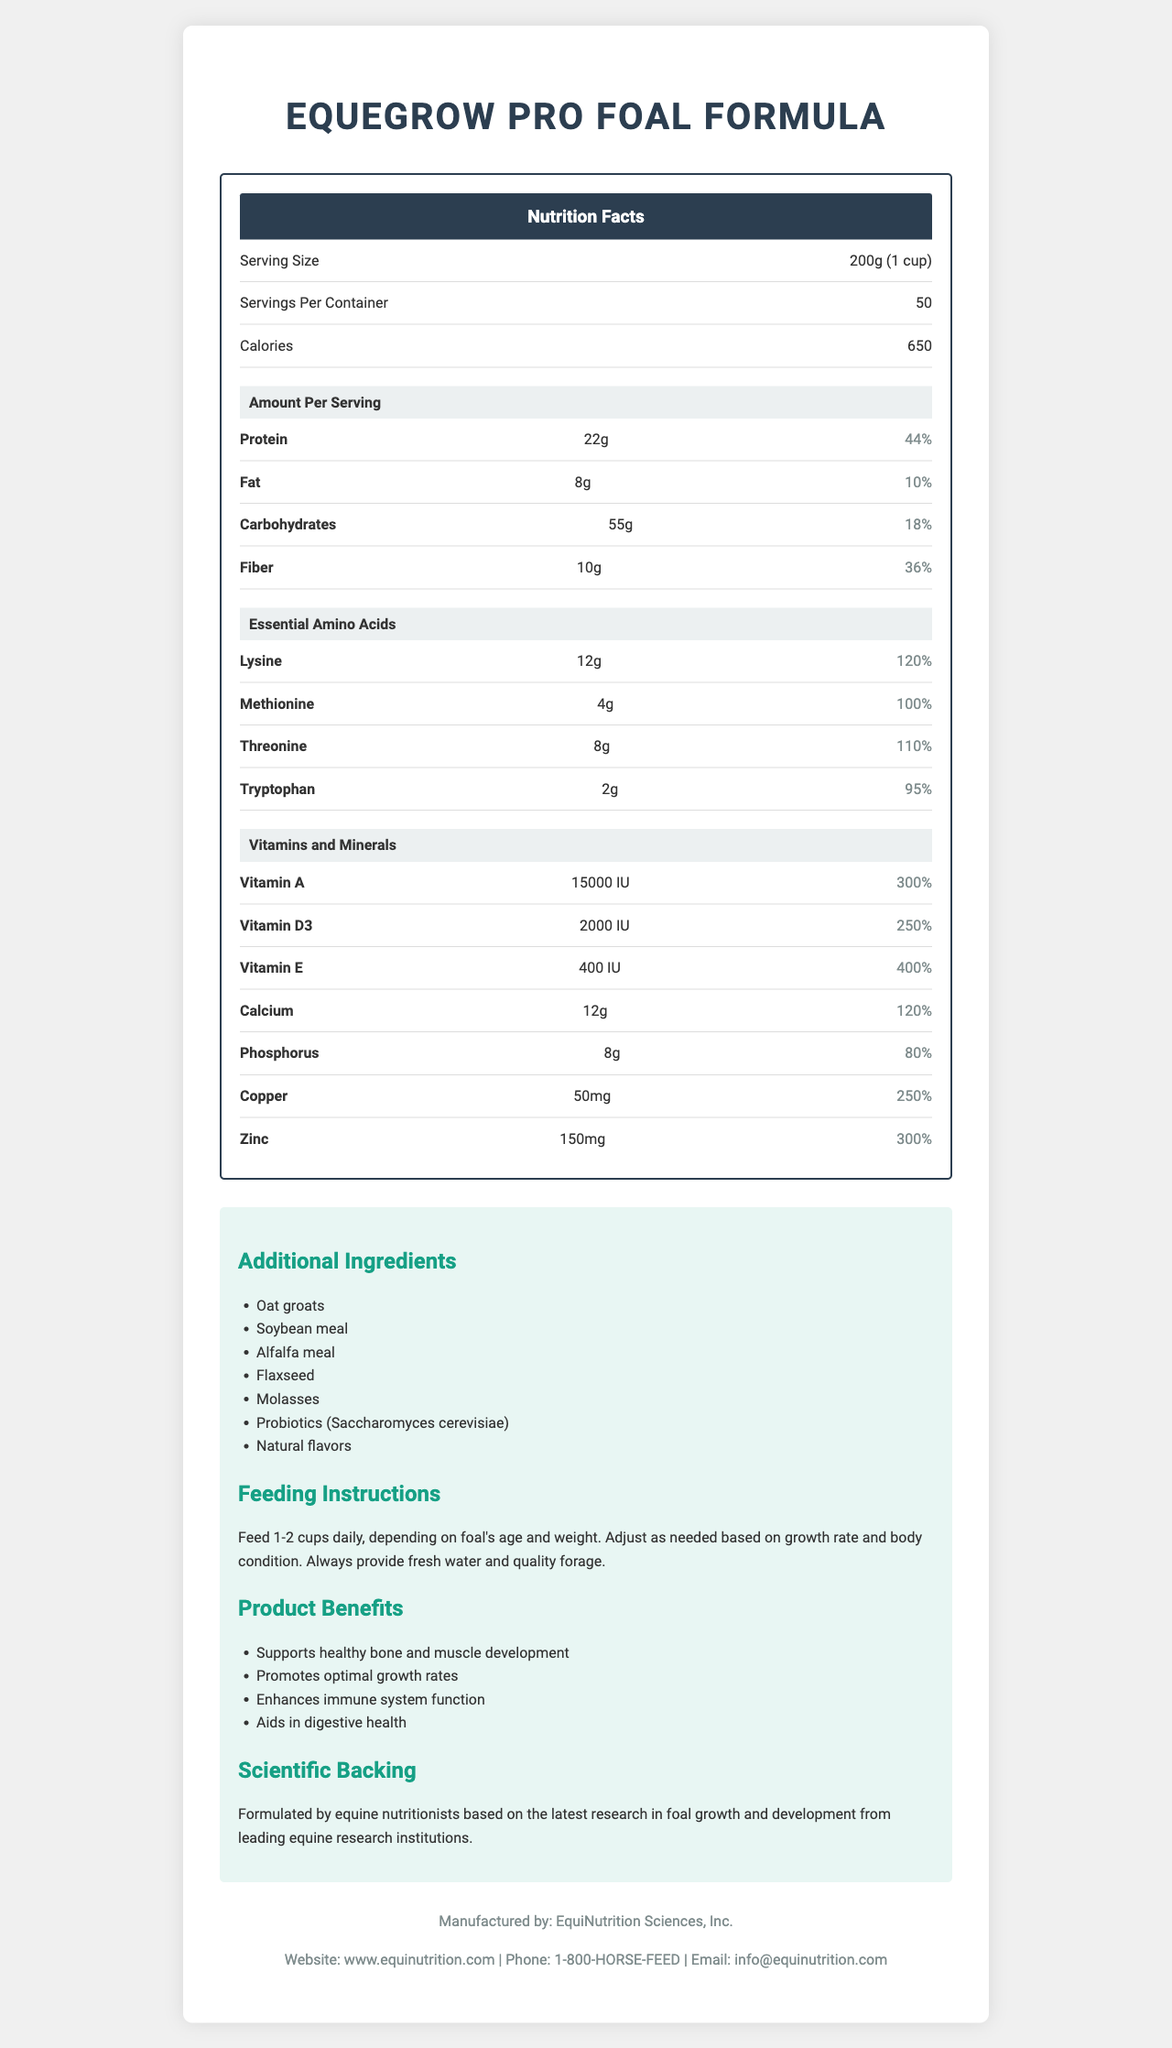what is the product name? The product name is stated at the top of the document and in the title section.
Answer: EqueGrow Pro Foal Formula what is the serving size? The serving size is mentioned under the Nutrition Facts section at the beginning of the document.
Answer: 200g (1 cup) how many calories per serving does this product have? The calories per serving are listed in the Nutrition Facts section under the section "Calories".
Answer: 650 how much protein is in each serving? The amount of protein per serving is detailed in the Nutrition Facts section under "Amount Per Serving".
Answer: 22g List three main product benefits from this supplement. These benefits are listed under the "Product Benefits" section in the document.
Answer: Supports healthy bone and muscle development, Promotes optimal growth rates, Enhances immune system function which essential amino acid has the highest daily value percentage? A. Lysine B. Methionine C. Threonine The daily value for Lysine is 120%, which is higher than Methionine (100%) and Threonine (110%).
Answer: A. Lysine how much Vitamin A is included per serving? The amount of Vitamin A per serving is specified under the "Vitamins and Minerals" section.
Answer: 15000 IU how many servings are in one container of this product? The document lists the number of servings per container as 50 in the Nutrition Facts section.
Answer: 50 what is the recommended daily feeding amount for foals based on age and weight? A. 1-2 cups B. 2-3 cups C. 3-4 cups The feeding recommendation states "Feed 1-2 cups daily, depending on foal's age and weight" under the "Feeding Instructions" section.
Answer: A. 1-2 cups is the information about the ingredient 'Soybean meal' included in the additional ingredients list? The additional ingredients section includes "Soybean meal".
Answer: Yes what is the primary target audience for this nutritional supplement? The product is formulated specifically for foal growth and development as indicated by the product name and the contents of the document.
Answer: Foals summarize the main idea of the document. This document presents detailed information about a nutritional supplement (EqueGrow Pro Foal Formula) for foals, including serving size, nutrient content, essential amino acids, vitamins, feeding instructions, and benefits.
Answer: The nutrition facts label for EqueGrow Pro Foal Formula provides comprehensive information about the product's nutritional profile, including essential amino acids and vitamins, aimed at supporting foal growth and development. The document highlights the ingredients, feeding instructions, product benefits, and scientific backing, along with manufacturer and contact information. what is the source of scientific backing for this product? The "Scientific Backing" section provides this information clearly.
Answer: Formulated by equine nutritionists based on the latest research in foal growth and development from leading equine research institutions what is the phone number for EquiNutrition Sciences, Inc.? This contact information is listed in the "contact information" section at the end of the document.
Answer: 1-800-HORSE-FEED how much fiber is present in a serving, and what is its daily value percentage? Under "Amount Per Serving" in the Nutrition Facts section, Fiber is listed with an amount of 10g and a daily value of 36%.
Answer: 10g; 36% how many milligrams of zinc are included in each serving? The zinc content is listed under the "Vitamins and Minerals" section.
Answer: 150mg does the supplement enhance the immune system function? One of the listed product benefits in the "Product Benefits" section is "Enhances immune system function".
Answer: Yes what is the percentage of the daily value for phosphorus in one serving? The document specifies the daily value percentage for phosphorus under "Vitamins and Minerals".
Answer: 80% how is the document visually formatted? This detailed explanation summarizes the key visual formatting elements of the document.
Answer: The document is well-structured with clear sections: Nutrition Facts, Essential Amino Acids, Vitamins and Minerals, Additional Ingredients, Feeding Instructions, Product Benefits, Scientific Backing, and Contact Information. It uses different section headers and visual styling for readability. are the exact quantities for each additional ingredient provided? The document lists the names of additional ingredients without specifying their exact quantities.
Answer: No 